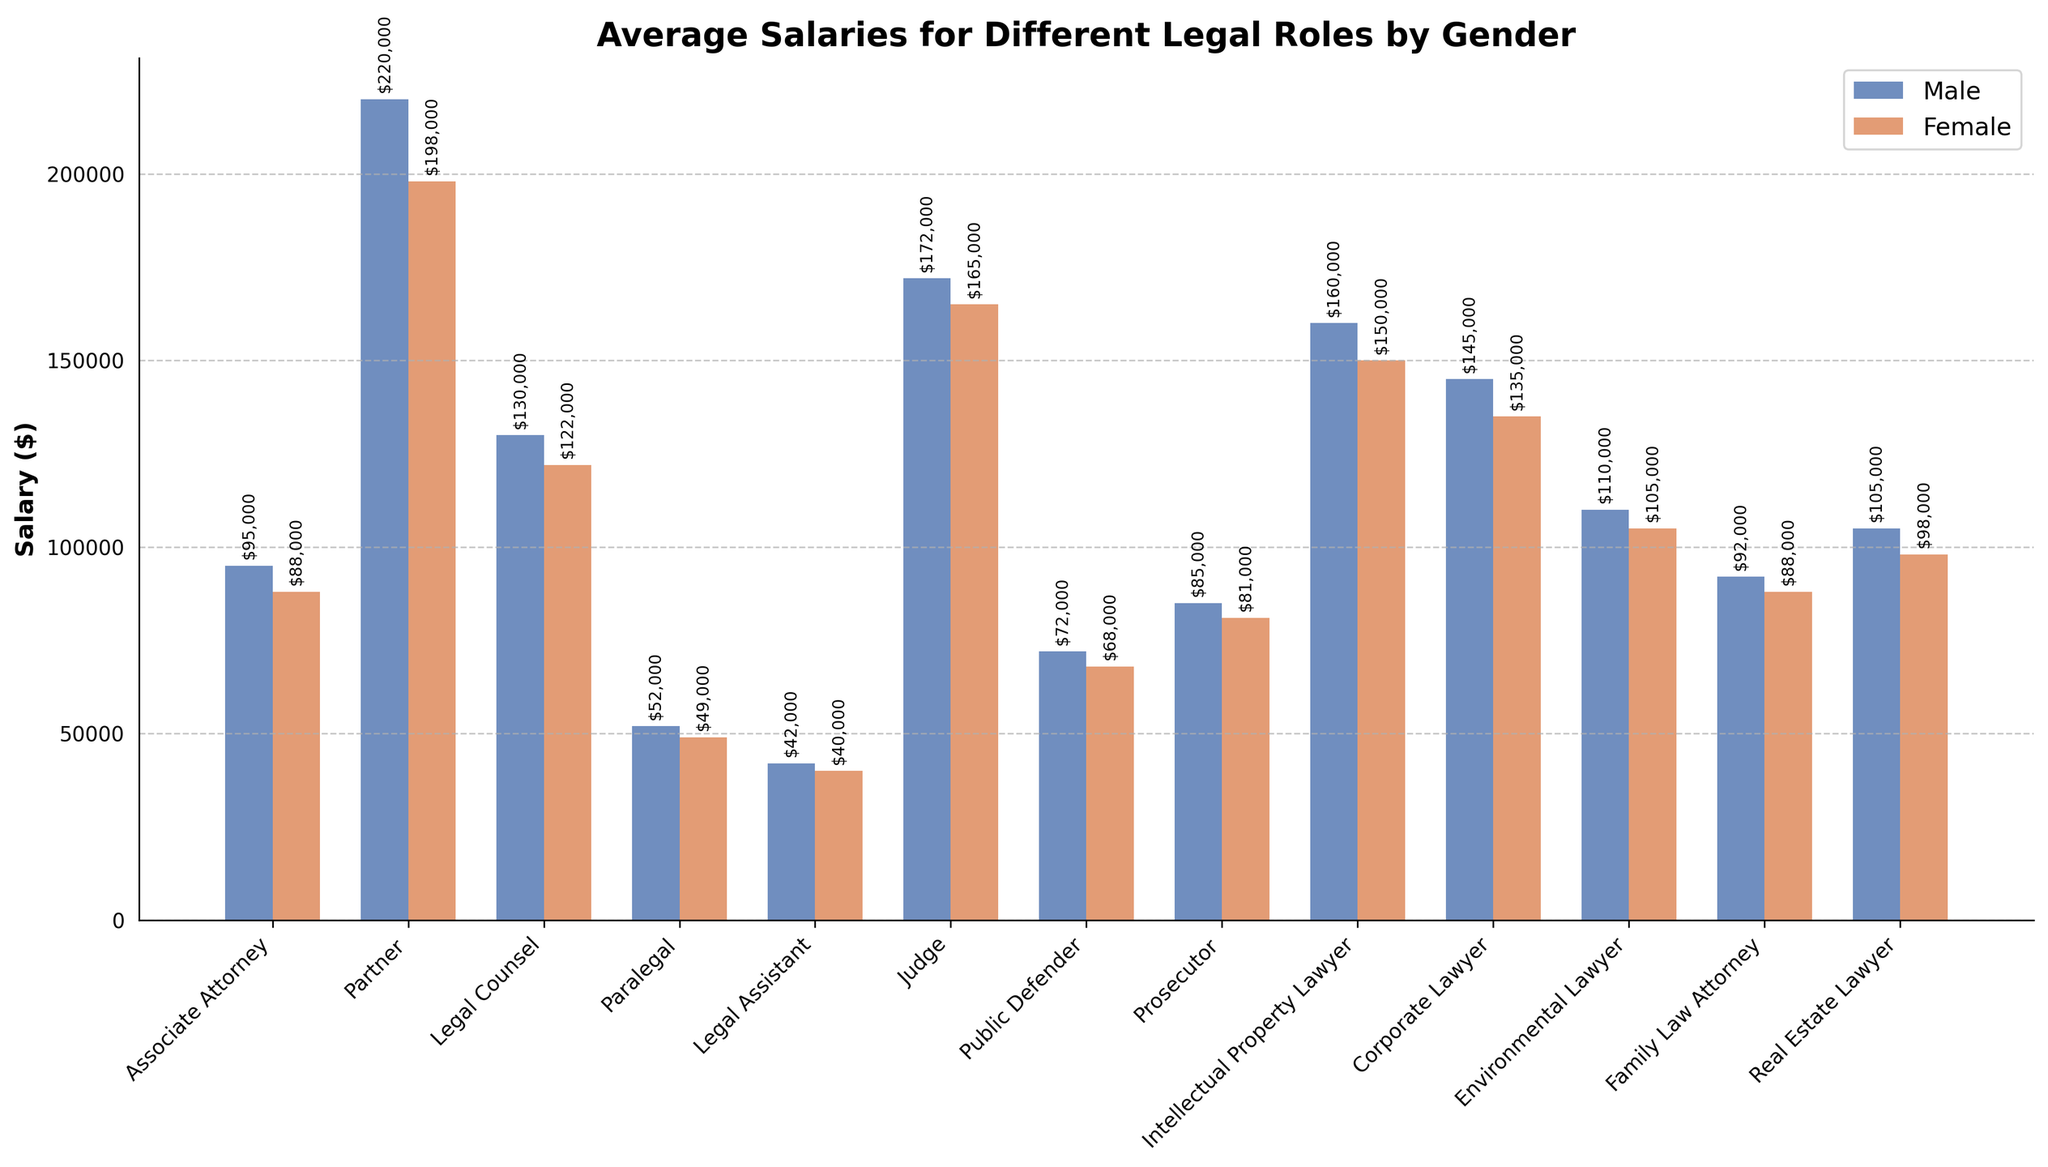What legal role has the highest average salary for males? From the bar chart, we identify the tallest blue bar that indicates the highest salary for males. The role with this highest salary is "Partner," with $220,000.
Answer: Partner Which legal role has the smallest gap between male and female average salaries? To determine this, observe each bar pair difference between male (blue) and female (red) salaries. "Legal Assistant" has the smallest gap, with male salary at $42,000 and female salary at $40,000, a difference of $2,000.
Answer: Legal Assistant Between which two legal roles is the female average salary closest? Comparing the heights of the red bars for female salaries, "Associate Attorney" and "Family Law Attorney" both show average salaries close to $88,000, indicating they are closest in value.
Answer: Associate Attorney and Family Law Attorney What is the total average salary for males in the roles of Judge and Corporate Lawyer? Sum the male salaries for "Judge" and "Corporate Lawyer"; $172,000 (Judge) + $145,000 (Corporate Lawyer) = $317,000.
Answer: $317,000 Which gender has a higher average salary for Paralegal, and by how much? Observing the bar corresponding to "Paralegal," the blue bar (male) appears higher, indicating a higher salary of $52,000 compared to the red bar (female) at $49,000. The difference is $52,000 - $49,000 = $3,000.
Answer: Male, $3,000 What is the average salary difference between males and females for Environmental Lawyer? From the bar chart, find the salaries for Environmental Lawyer: Male ($110,000) and Female ($105,000). The difference is $110,000 - $105,000 = $5,000.
Answer: $5,000 Which legal role shows the highest female salary and how much is it? By identifying the tallest red bar in the chart, "Partner" shows the highest female salary of $198,000.
Answer: Partner, $198,000 How does the average male salary for Public Defender compare to the average female salary for Prosecutor? From the chart, compare the average male salary for Public Defender ($72,000) to the female salary for Prosecutor ($81,000). $81,000 (female, Prosecutor) - $72,000 (male, Public Defender) = $9,000.
Answer: Female Prosecutor salary is $9,000 higher Is the average salary for female Corporate Lawyers higher than the average salary for male Legal Counsel? Observe the respective bars: female Corporate Lawyer ($135,000) and male Legal Counsel ($130,000). Since $135,000 > $130,000, the female Corporate Lawyer salary is higher.
Answer: Yes What is the approximate difference in salary between the highest-paid male role and the highest-paid female role? The highest-paid male role is “Partner” ($220,000), and the highest-paid female role is also “Partner” ($198,000). The difference is $220,000 - $198,000 = $22,000.
Answer: $22,000 